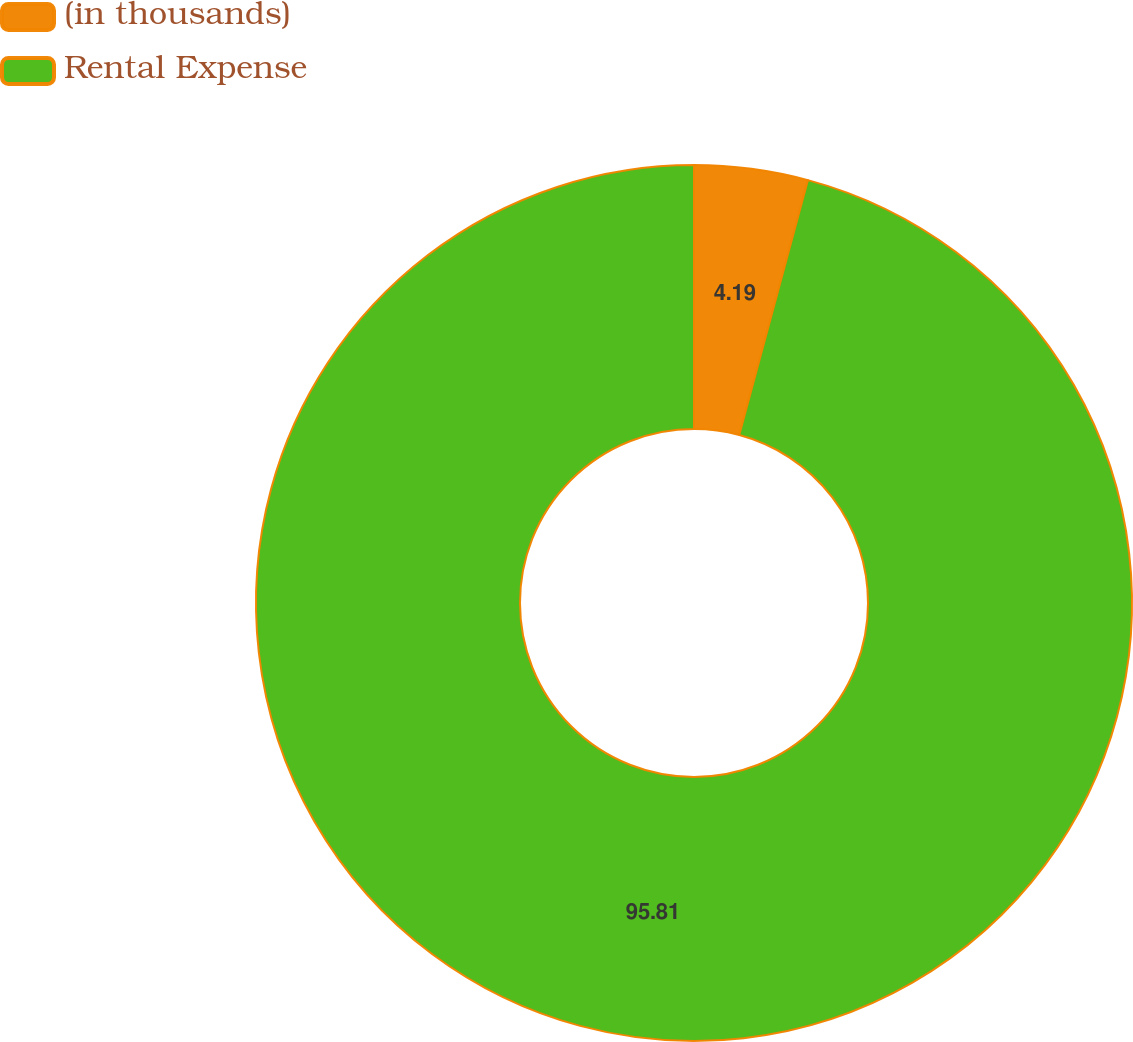Convert chart. <chart><loc_0><loc_0><loc_500><loc_500><pie_chart><fcel>(in thousands)<fcel>Rental Expense<nl><fcel>4.19%<fcel>95.81%<nl></chart> 